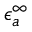Convert formula to latex. <formula><loc_0><loc_0><loc_500><loc_500>\epsilon _ { a } ^ { \infty }</formula> 